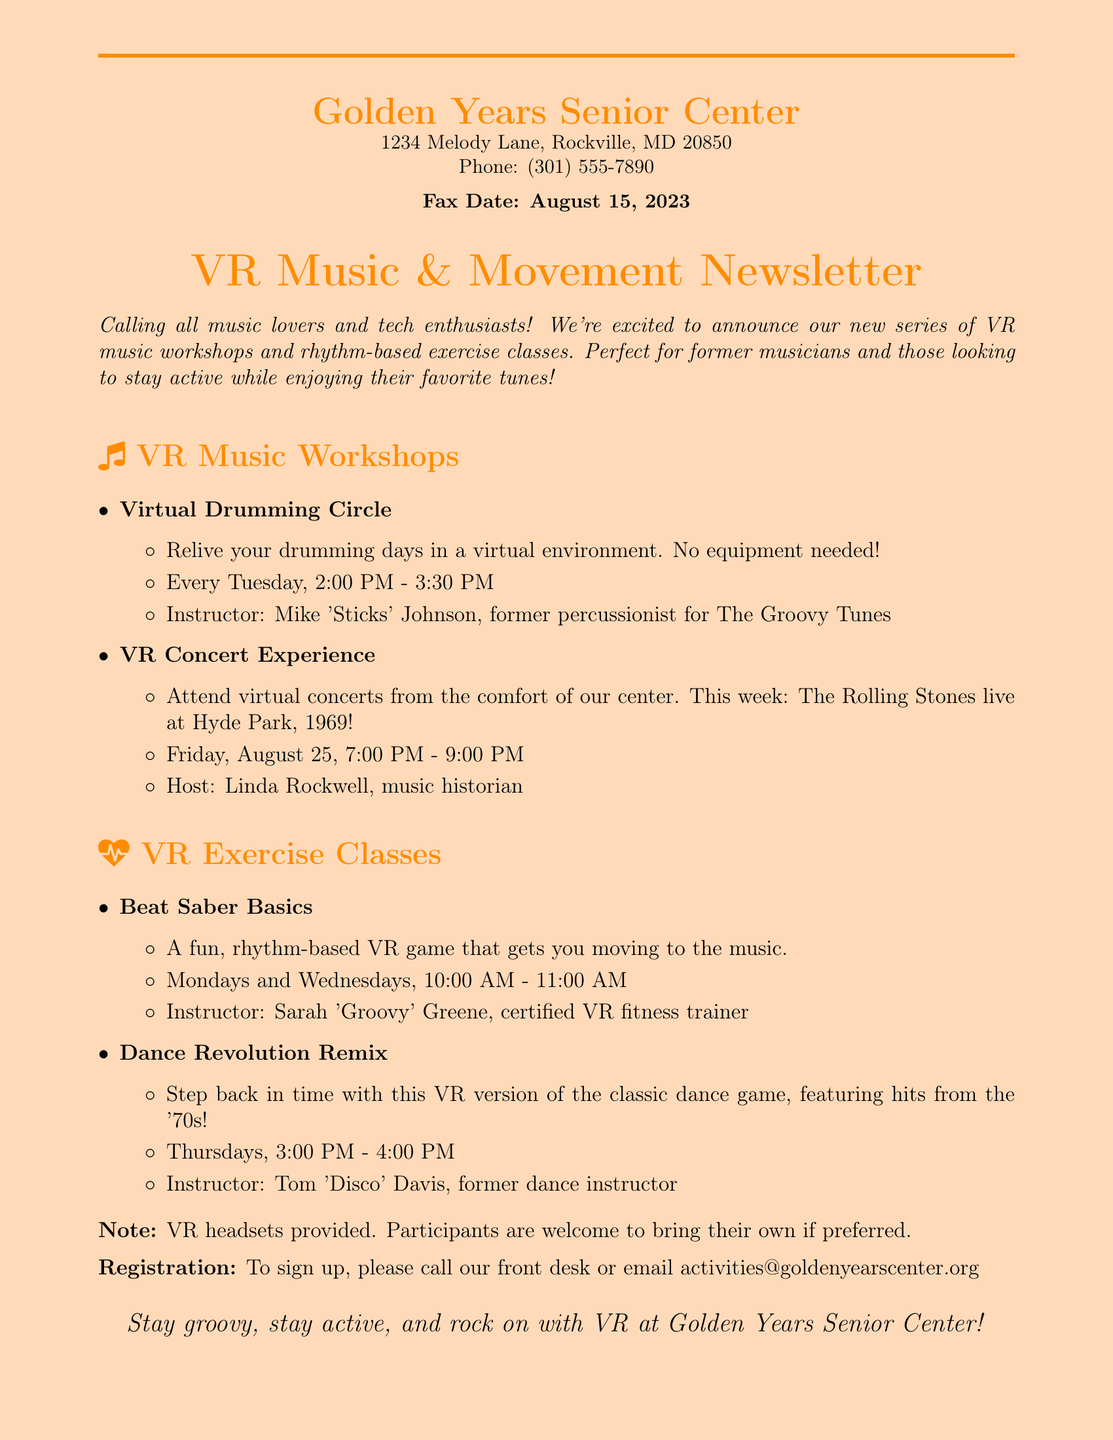What is the address of the Golden Years Senior Center? The address is found in the document at the top where it lists the center’s details.
Answer: 1234 Melody Lane, Rockville, MD 20850 Who is the instructor for the Virtual Drumming Circle? The instructor's name is listed under the section for VR Music Workshops in the item for the Virtual Drumming Circle.
Answer: Mike 'Sticks' Johnson What day and time does the Dance Revolution Remix class take place? The document specifies the schedule for the Dance Revolution Remix class in the VR Exercise Classes section.
Answer: Thursdays, 3:00 PM - 4:00 PM How long is each VR Music Workshop session? The duration of the workshops is included in the details listed under each activity.
Answer: 1.5 hours What type of VR experience is featured on August 25? Information about upcoming virtual events is shared specifically in the VR Concert Experience item.
Answer: The Rolling Stones live at Hyde Park, 1969 How can participants sign up for the workshops? Registration information is provided at the end of the document.
Answer: Call our front desk or email activities@goldenyearscenter.org What is provided for the participants in the VR classes? The document outlines what resources are available for participants in the classes.
Answer: VR headsets What is the main theme of the newsletter? The primary focus of the newsletter is indicated in the title and introductory text.
Answer: VR music workshops and rhythm-based exercise classes 